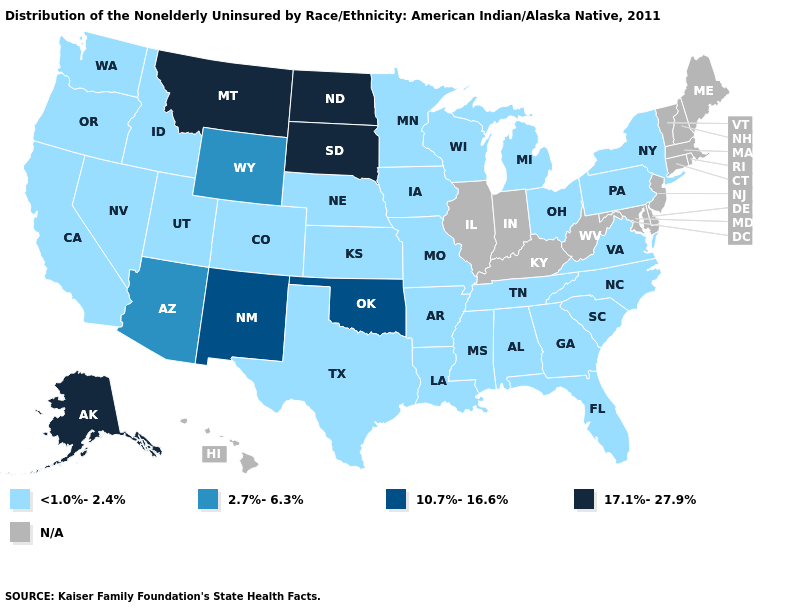What is the value of Ohio?
Be succinct. <1.0%-2.4%. Name the states that have a value in the range 10.7%-16.6%?
Answer briefly. New Mexico, Oklahoma. What is the highest value in states that border Georgia?
Keep it brief. <1.0%-2.4%. Name the states that have a value in the range N/A?
Short answer required. Connecticut, Delaware, Hawaii, Illinois, Indiana, Kentucky, Maine, Maryland, Massachusetts, New Hampshire, New Jersey, Rhode Island, Vermont, West Virginia. Does Oklahoma have the highest value in the South?
Give a very brief answer. Yes. What is the value of Pennsylvania?
Answer briefly. <1.0%-2.4%. Which states hav the highest value in the MidWest?
Be succinct. North Dakota, South Dakota. Which states have the lowest value in the West?
Write a very short answer. California, Colorado, Idaho, Nevada, Oregon, Utah, Washington. Which states hav the highest value in the MidWest?
Keep it brief. North Dakota, South Dakota. Which states hav the highest value in the South?
Answer briefly. Oklahoma. Name the states that have a value in the range 17.1%-27.9%?
Write a very short answer. Alaska, Montana, North Dakota, South Dakota. 